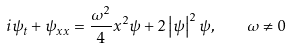Convert formula to latex. <formula><loc_0><loc_0><loc_500><loc_500>i \psi _ { t } + \psi _ { x x } = \frac { \omega ^ { 2 } } { 4 } x ^ { 2 } \psi + 2 \left | \psi \right | ^ { 2 } \psi , \quad \omega \neq 0</formula> 